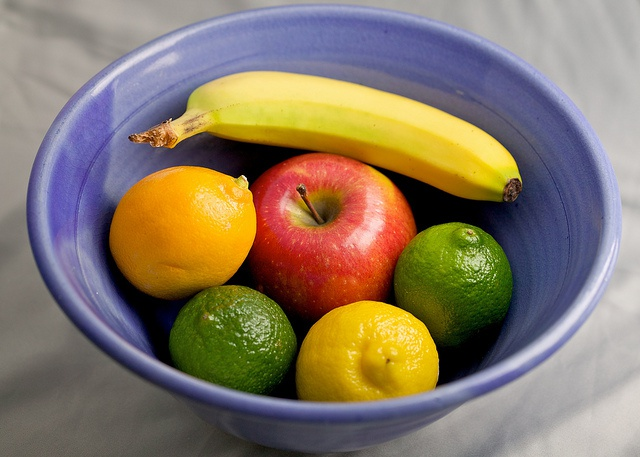Describe the objects in this image and their specific colors. I can see bowl in darkgray, gray, black, purple, and orange tones, banana in darkgray, khaki, gold, and olive tones, apple in darkgray, brown, salmon, red, and maroon tones, and orange in darkgray, orange, olive, and gold tones in this image. 